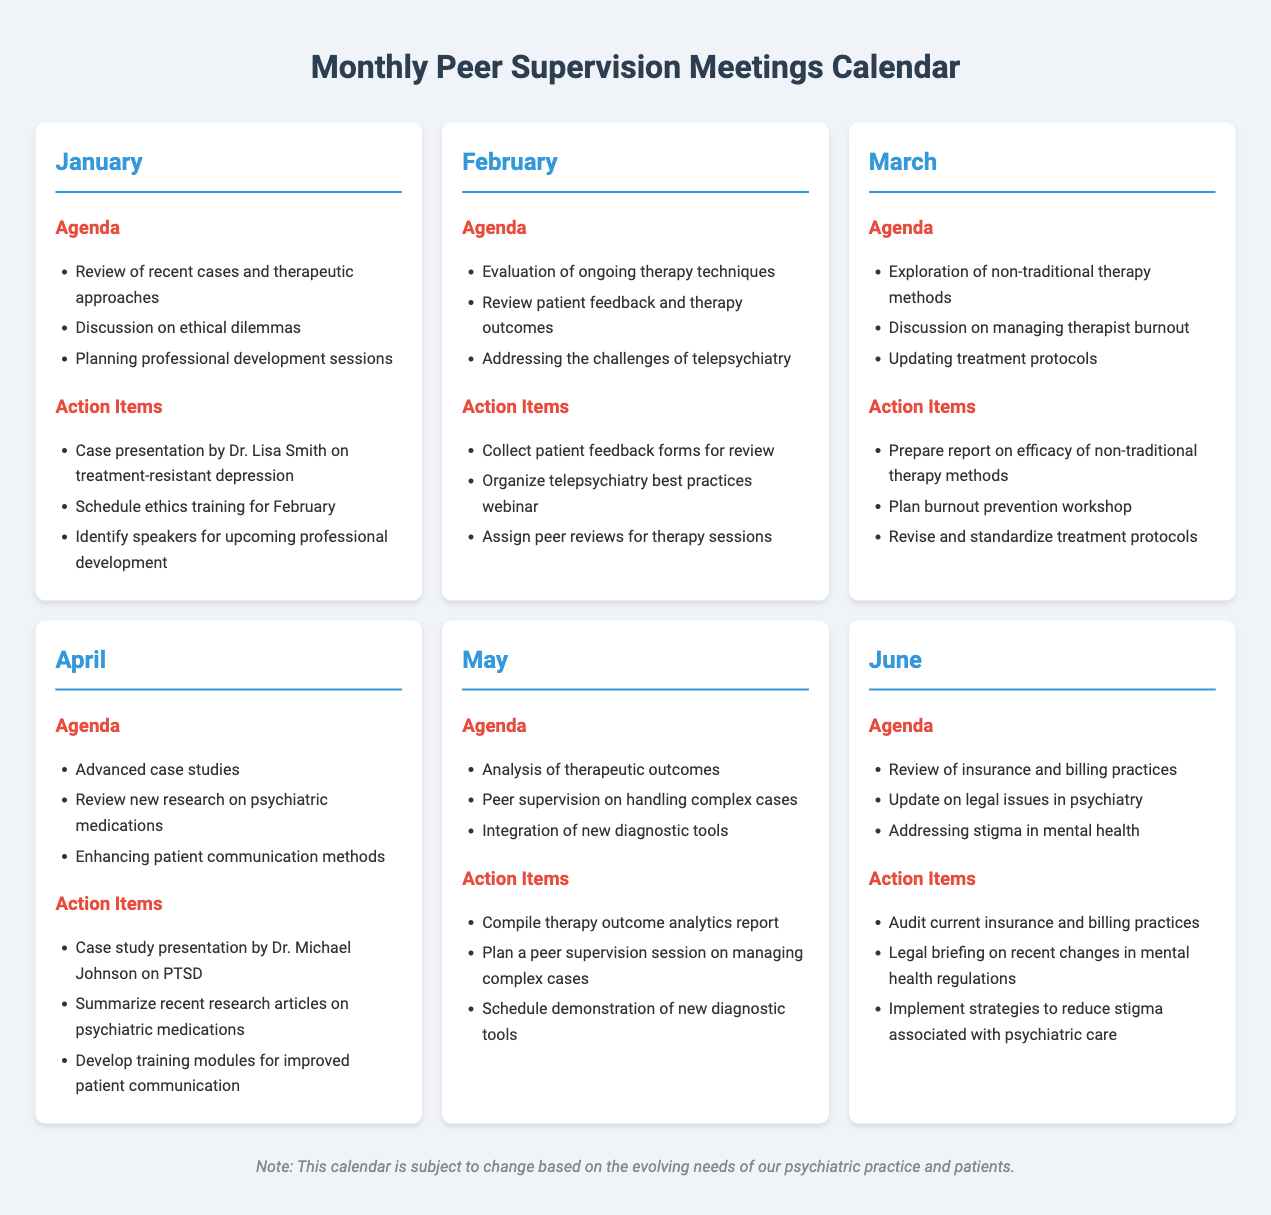What is the agenda for May? The agenda for May includes the analysis of therapeutic outcomes, peer supervision on handling complex cases, and integration of new diagnostic tools.
Answer: Analysis of therapeutic outcomes, peer supervision on handling complex cases, integration of new diagnostic tools Who is presenting in April? The action item for April specifies that Dr. Michael Johnson is presenting a case study on PTSD.
Answer: Dr. Michael Johnson What action item is scheduled for February? The action items for February include collecting patient feedback forms for review, organizing a telepsychiatry best practices webinar, and assigning peer reviews for therapy sessions.
Answer: Collect patient feedback forms for review How many months are covered in the document? The document details supervision meetings from January to June, constituting a total of six months.
Answer: Six What is discussed in March regarding therapist well-being? The agenda mentions the discussion on managing therapist burnout as a key topic for March's meeting.
Answer: Managing therapist burnout What is a common theme across the agendas? A recurring theme across the agendas is the focus on evaluating and improving therapeutic methods and practices.
Answer: Evaluating and improving therapeutic methods What action item relates to stigma in June? The action item for June states the implementation of strategies to reduce stigma associated with psychiatric care.
Answer: Implement strategies to reduce stigma associated with psychiatric care Which month addresses ethical dilemmas? The agenda for January specifically includes a discussion on ethical dilemmas in psychiatric practice.
Answer: January What training is scheduled for April? The action items for April include the development of training modules for improved patient communication.
Answer: Training modules for improved patient communication 